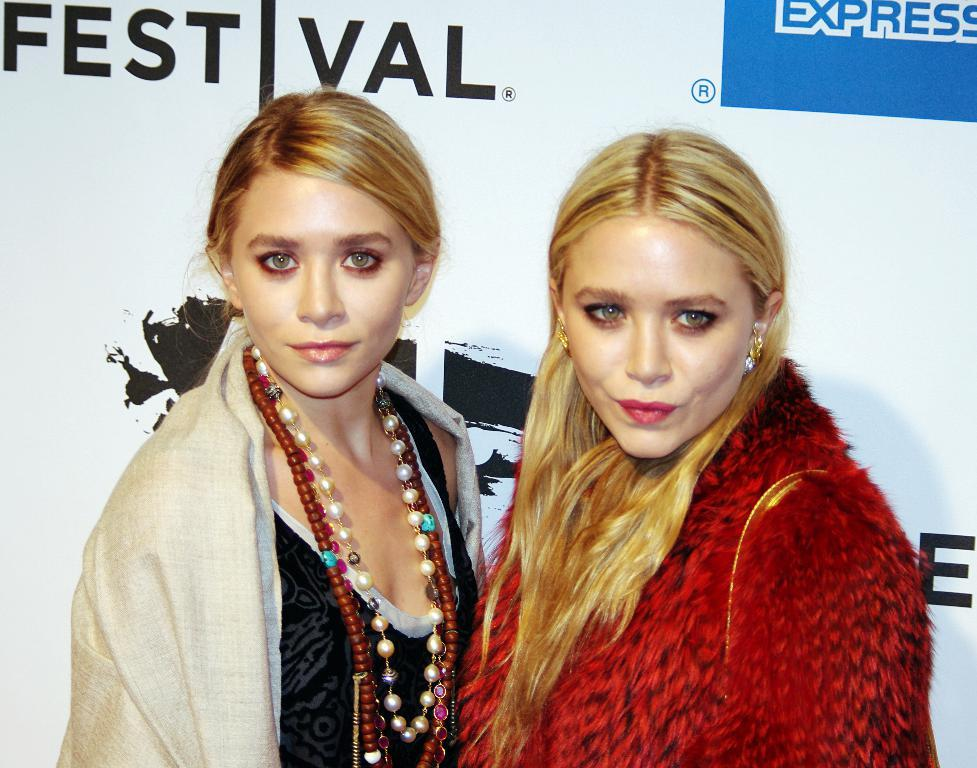How many people are in the image? There are two women standing in the image. What is located behind the women? There is a banner behind the women. What can be seen on the banner? The banner has images and text on it. Where is the nearest park to the location of the women in the image? The provided facts do not give any information about the location of the women or the presence of a park, so it cannot be determined from the image. 